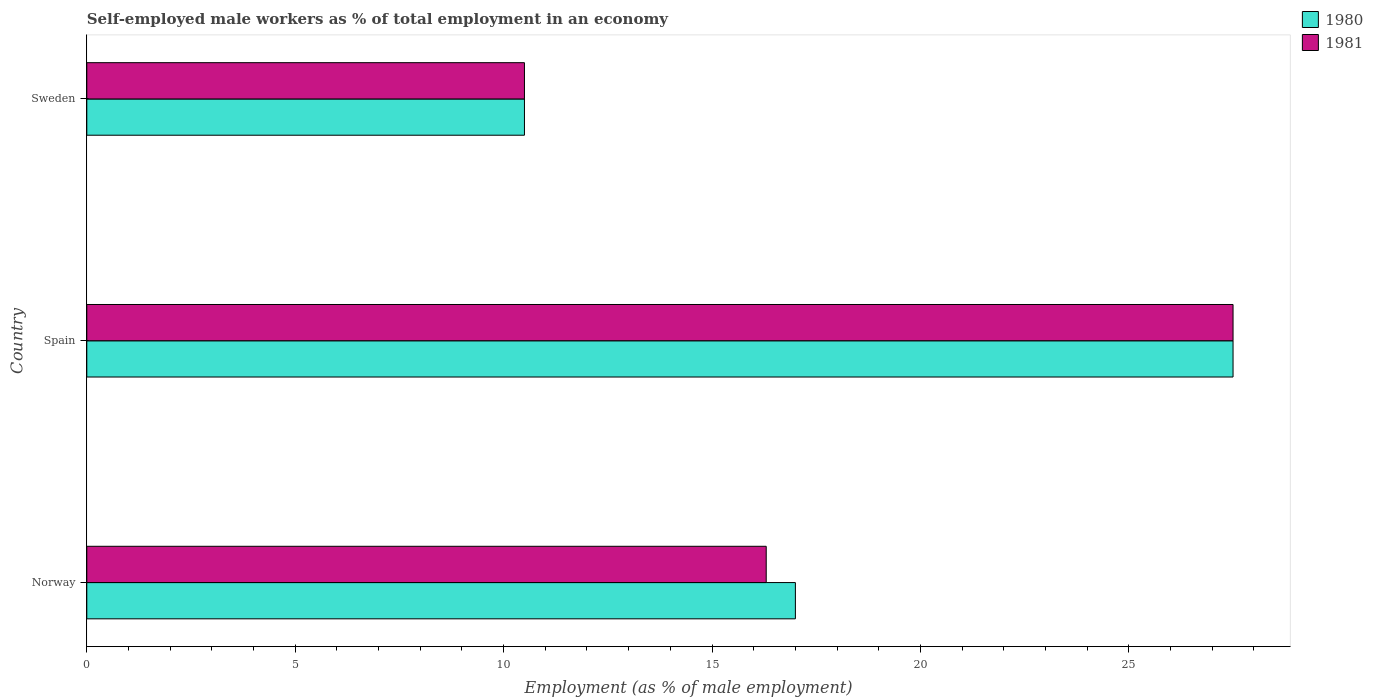How many different coloured bars are there?
Make the answer very short. 2. Are the number of bars per tick equal to the number of legend labels?
Keep it short and to the point. Yes. What is the label of the 2nd group of bars from the top?
Ensure brevity in your answer.  Spain. Across all countries, what is the minimum percentage of self-employed male workers in 1981?
Your answer should be compact. 10.5. In which country was the percentage of self-employed male workers in 1980 minimum?
Provide a short and direct response. Sweden. What is the total percentage of self-employed male workers in 1980 in the graph?
Offer a terse response. 55. What is the difference between the percentage of self-employed male workers in 1981 in Norway and that in Sweden?
Keep it short and to the point. 5.8. What is the average percentage of self-employed male workers in 1980 per country?
Provide a short and direct response. 18.33. What is the difference between the percentage of self-employed male workers in 1980 and percentage of self-employed male workers in 1981 in Sweden?
Provide a short and direct response. 0. In how many countries, is the percentage of self-employed male workers in 1981 greater than 2 %?
Make the answer very short. 3. What is the ratio of the percentage of self-employed male workers in 1981 in Spain to that in Sweden?
Your answer should be compact. 2.62. What is the difference between the highest and the second highest percentage of self-employed male workers in 1980?
Offer a terse response. 10.5. In how many countries, is the percentage of self-employed male workers in 1980 greater than the average percentage of self-employed male workers in 1980 taken over all countries?
Make the answer very short. 1. How many bars are there?
Your answer should be very brief. 6. How many countries are there in the graph?
Ensure brevity in your answer.  3. How many legend labels are there?
Offer a terse response. 2. What is the title of the graph?
Your answer should be very brief. Self-employed male workers as % of total employment in an economy. What is the label or title of the X-axis?
Provide a succinct answer. Employment (as % of male employment). What is the label or title of the Y-axis?
Your response must be concise. Country. What is the Employment (as % of male employment) of 1980 in Norway?
Keep it short and to the point. 17. What is the Employment (as % of male employment) of 1981 in Norway?
Ensure brevity in your answer.  16.3. What is the Employment (as % of male employment) in 1980 in Spain?
Your answer should be compact. 27.5. Across all countries, what is the maximum Employment (as % of male employment) of 1980?
Your answer should be very brief. 27.5. Across all countries, what is the maximum Employment (as % of male employment) in 1981?
Provide a short and direct response. 27.5. What is the total Employment (as % of male employment) of 1981 in the graph?
Offer a terse response. 54.3. What is the difference between the Employment (as % of male employment) in 1980 in Norway and that in Sweden?
Offer a terse response. 6.5. What is the difference between the Employment (as % of male employment) of 1980 in Spain and that in Sweden?
Give a very brief answer. 17. What is the difference between the Employment (as % of male employment) of 1980 in Spain and the Employment (as % of male employment) of 1981 in Sweden?
Your answer should be very brief. 17. What is the average Employment (as % of male employment) in 1980 per country?
Your answer should be compact. 18.33. What is the average Employment (as % of male employment) of 1981 per country?
Provide a short and direct response. 18.1. What is the difference between the Employment (as % of male employment) of 1980 and Employment (as % of male employment) of 1981 in Spain?
Provide a short and direct response. 0. What is the difference between the Employment (as % of male employment) in 1980 and Employment (as % of male employment) in 1981 in Sweden?
Make the answer very short. 0. What is the ratio of the Employment (as % of male employment) of 1980 in Norway to that in Spain?
Provide a short and direct response. 0.62. What is the ratio of the Employment (as % of male employment) in 1981 in Norway to that in Spain?
Your response must be concise. 0.59. What is the ratio of the Employment (as % of male employment) of 1980 in Norway to that in Sweden?
Provide a succinct answer. 1.62. What is the ratio of the Employment (as % of male employment) in 1981 in Norway to that in Sweden?
Make the answer very short. 1.55. What is the ratio of the Employment (as % of male employment) in 1980 in Spain to that in Sweden?
Your answer should be very brief. 2.62. What is the ratio of the Employment (as % of male employment) in 1981 in Spain to that in Sweden?
Give a very brief answer. 2.62. What is the difference between the highest and the second highest Employment (as % of male employment) of 1980?
Ensure brevity in your answer.  10.5. What is the difference between the highest and the second highest Employment (as % of male employment) in 1981?
Provide a short and direct response. 11.2. What is the difference between the highest and the lowest Employment (as % of male employment) of 1980?
Offer a terse response. 17. What is the difference between the highest and the lowest Employment (as % of male employment) of 1981?
Make the answer very short. 17. 